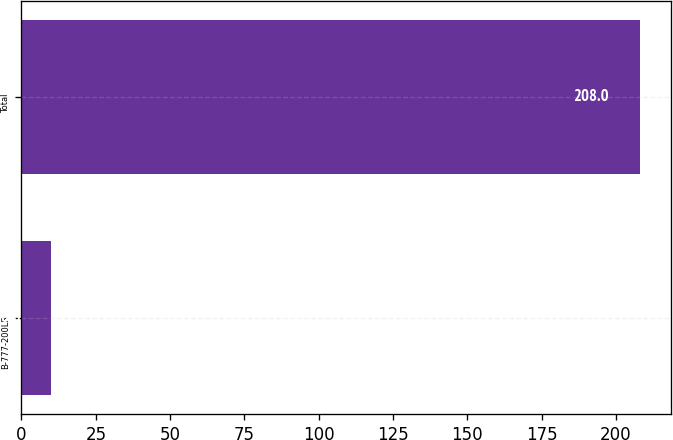<chart> <loc_0><loc_0><loc_500><loc_500><bar_chart><fcel>B-777-200LR<fcel>Total<nl><fcel>10<fcel>208<nl></chart> 